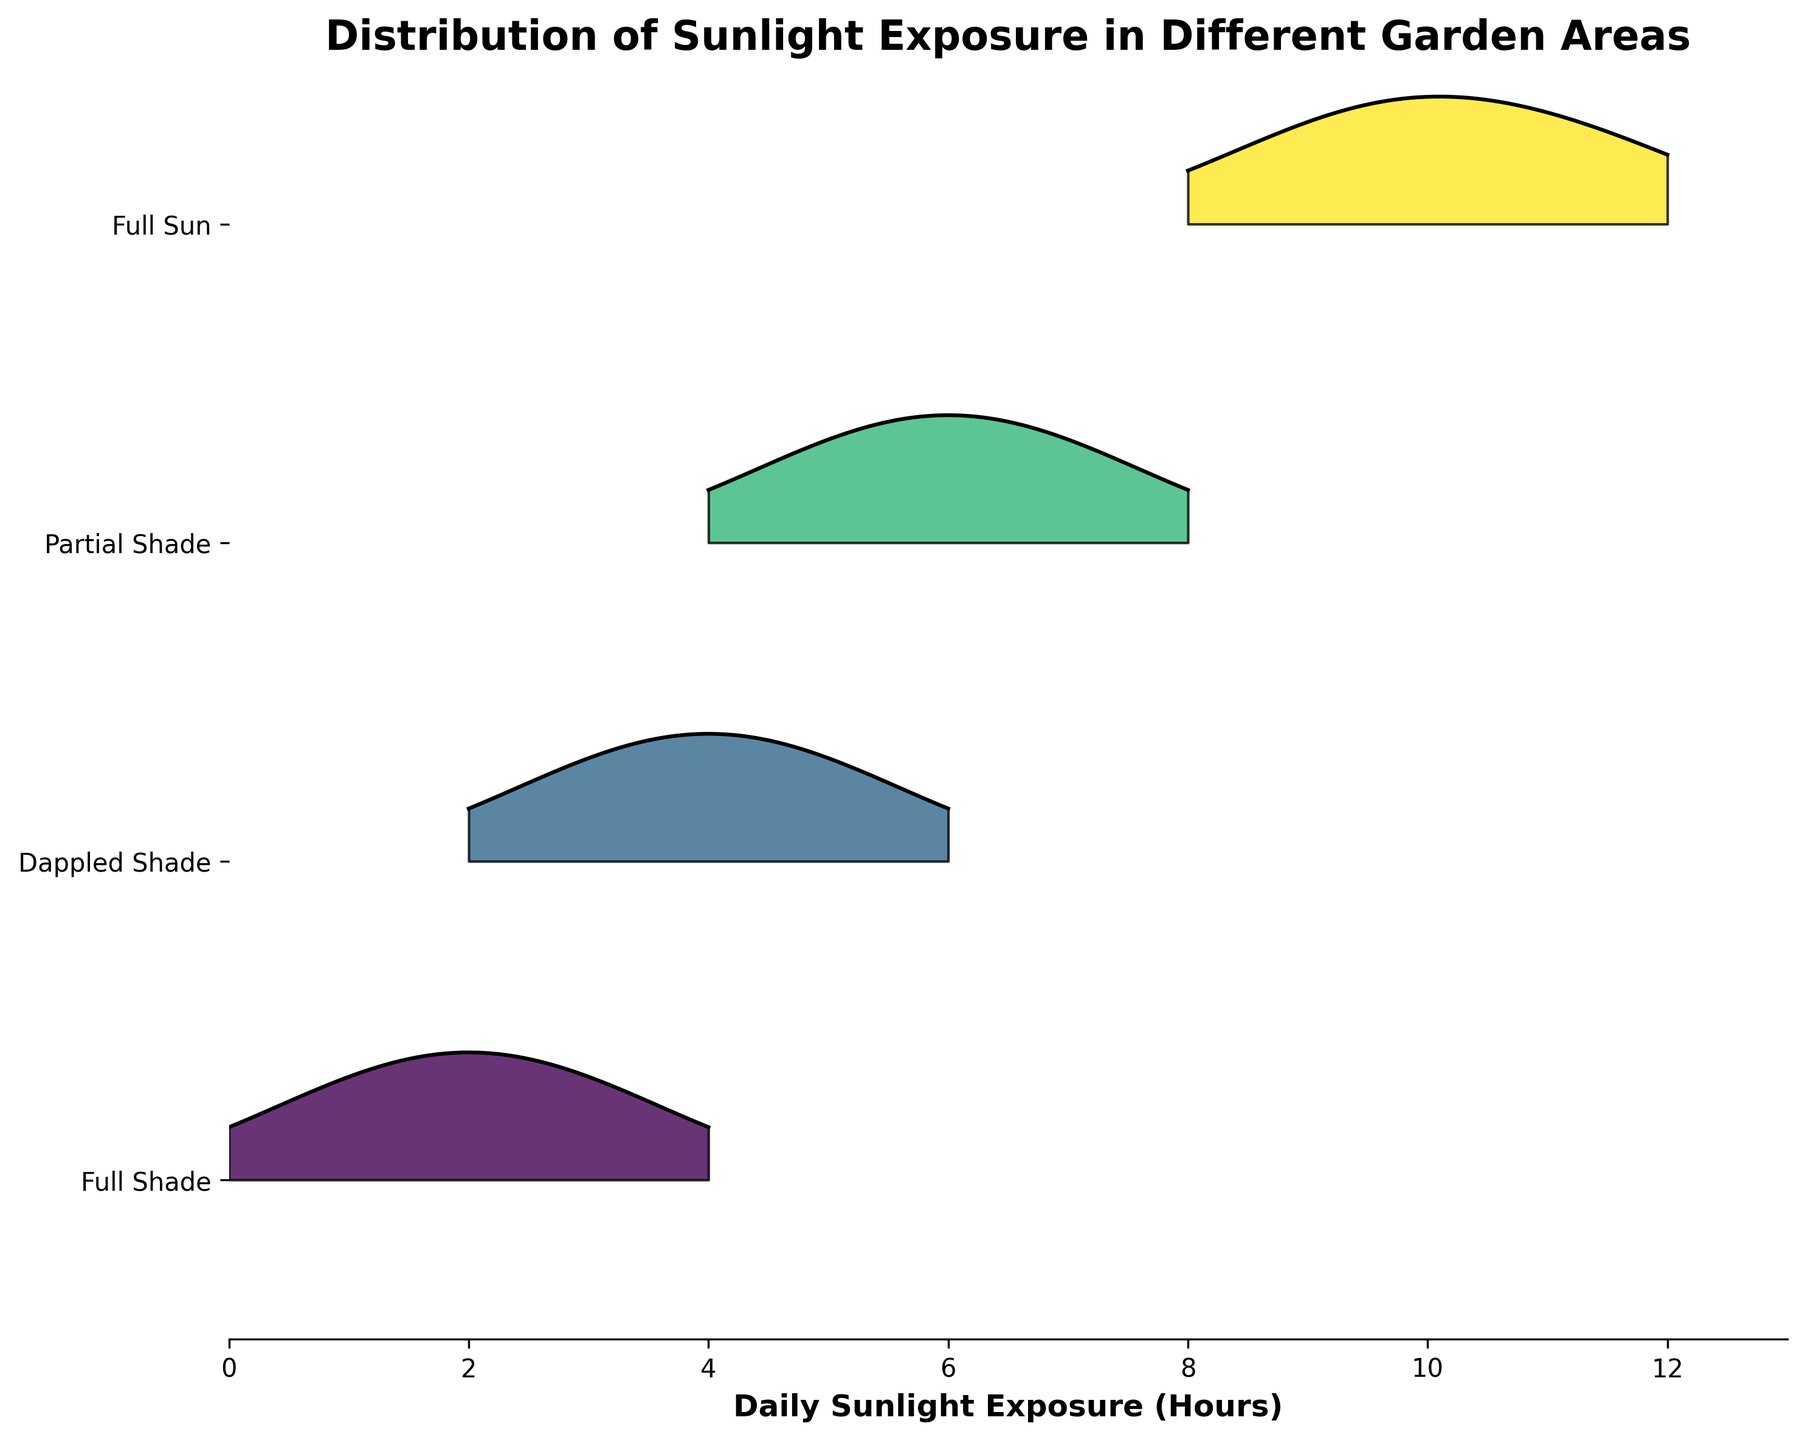What's the title of the plot? The title of the plot is usually found at the top center of the figure. The specific title given for this ridgeline plot can be read directly from the plot.
Answer: Distribution of Sunlight Exposure in Different Garden Areas What does the x-axis represent? The x-axis label is located below the horizontal axis on the plot. It clearly indicates what is being measured along the x-axis.
Answer: Daily Sunlight Exposure (Hours) Which area has the highest peak density in terms of sunlight exposure hours? The area with the highest peak density is identified by looking at the plot and identifying the area where the peak of the density curve reaches the highest vertical position.
Answer: Full Sun Which area receives the least amount of daily sunlight exposure? To determine which area receives the least amount of sunlight, look for the area where the distribution lies furthest to the left on the x-axis.
Answer: Full Shade How does the sunlight exposure distribution for Full Sun compare to Partial Shade? Compare the x-axis positions and shapes of the distribution curves for Full Sun and Partial Shade. Full Sun is concentrated on the right (8-12 hours) while Partial Shade is shifted left (4-8 hours).
Answer: Full Sun receives more hours of sunlight than Partial Shade What is the range of hours for the Dappled Shade area? Determine the range by observing the x-axis span of the distribution for the Dappled Shade area.
Answer: 2 to 6 hours Which two areas have overlapping sunlight exposure distributions? Identify overlapping areas by looking for distributions that cover similar ranges on the x-axis.
Answer: Partial Shade and Dappled Shade What is the general trend in sunlight exposure from Full Shade to Full Sun? Observe the overall shift in density curves from left to right across the areas from Full Shade to Full Sun, indicating changes in sunlight exposure.
Answer: Increasing sunlight exposure What is the peak density value for the Full Shade area? The peak density value can be inferred from the highest point of the distribution curve for the Full Shade area.
Answer: 0.4 